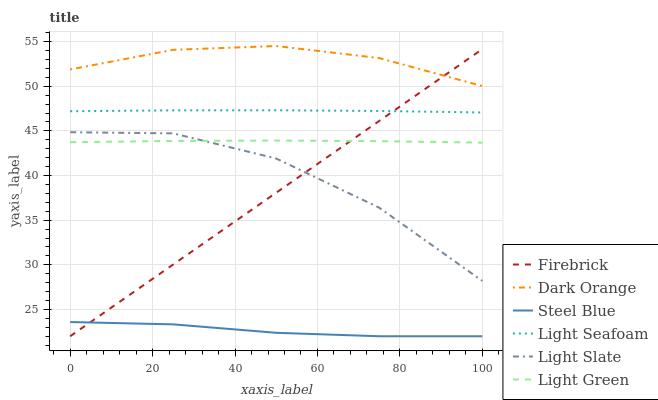Does Steel Blue have the minimum area under the curve?
Answer yes or no. Yes. Does Dark Orange have the maximum area under the curve?
Answer yes or no. Yes. Does Light Slate have the minimum area under the curve?
Answer yes or no. No. Does Light Slate have the maximum area under the curve?
Answer yes or no. No. Is Firebrick the smoothest?
Answer yes or no. Yes. Is Light Slate the roughest?
Answer yes or no. Yes. Is Light Slate the smoothest?
Answer yes or no. No. Is Firebrick the roughest?
Answer yes or no. No. Does Firebrick have the lowest value?
Answer yes or no. Yes. Does Light Slate have the lowest value?
Answer yes or no. No. Does Dark Orange have the highest value?
Answer yes or no. Yes. Does Light Slate have the highest value?
Answer yes or no. No. Is Steel Blue less than Light Seafoam?
Answer yes or no. Yes. Is Light Slate greater than Steel Blue?
Answer yes or no. Yes. Does Light Green intersect Light Slate?
Answer yes or no. Yes. Is Light Green less than Light Slate?
Answer yes or no. No. Is Light Green greater than Light Slate?
Answer yes or no. No. Does Steel Blue intersect Light Seafoam?
Answer yes or no. No. 